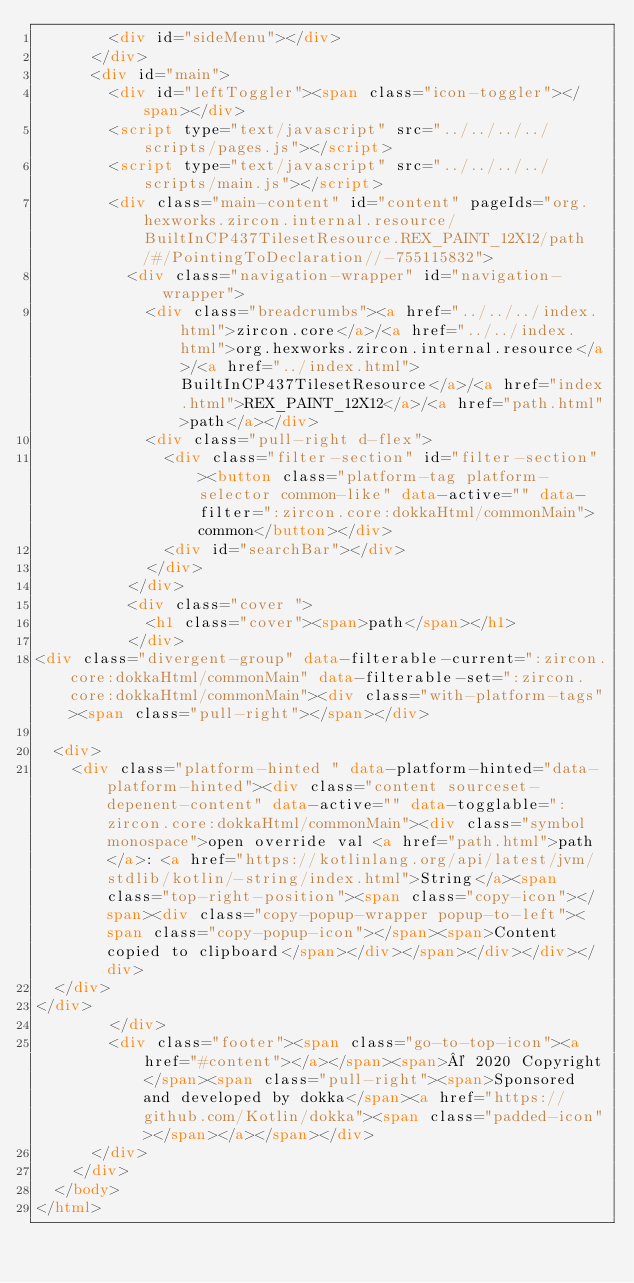<code> <loc_0><loc_0><loc_500><loc_500><_HTML_>        <div id="sideMenu"></div>
      </div>
      <div id="main">
        <div id="leftToggler"><span class="icon-toggler"></span></div>
        <script type="text/javascript" src="../../../../scripts/pages.js"></script>
        <script type="text/javascript" src="../../../../scripts/main.js"></script>
        <div class="main-content" id="content" pageIds="org.hexworks.zircon.internal.resource/BuiltInCP437TilesetResource.REX_PAINT_12X12/path/#/PointingToDeclaration//-755115832">
          <div class="navigation-wrapper" id="navigation-wrapper">
            <div class="breadcrumbs"><a href="../../../index.html">zircon.core</a>/<a href="../../index.html">org.hexworks.zircon.internal.resource</a>/<a href="../index.html">BuiltInCP437TilesetResource</a>/<a href="index.html">REX_PAINT_12X12</a>/<a href="path.html">path</a></div>
            <div class="pull-right d-flex">
              <div class="filter-section" id="filter-section"><button class="platform-tag platform-selector common-like" data-active="" data-filter=":zircon.core:dokkaHtml/commonMain">common</button></div>
              <div id="searchBar"></div>
            </div>
          </div>
          <div class="cover ">
            <h1 class="cover"><span>path</span></h1>
          </div>
<div class="divergent-group" data-filterable-current=":zircon.core:dokkaHtml/commonMain" data-filterable-set=":zircon.core:dokkaHtml/commonMain"><div class="with-platform-tags"><span class="pull-right"></span></div>

  <div>
    <div class="platform-hinted " data-platform-hinted="data-platform-hinted"><div class="content sourceset-depenent-content" data-active="" data-togglable=":zircon.core:dokkaHtml/commonMain"><div class="symbol monospace">open override val <a href="path.html">path</a>: <a href="https://kotlinlang.org/api/latest/jvm/stdlib/kotlin/-string/index.html">String</a><span class="top-right-position"><span class="copy-icon"></span><div class="copy-popup-wrapper popup-to-left"><span class="copy-popup-icon"></span><span>Content copied to clipboard</span></div></span></div></div></div>
  </div>
</div>
        </div>
        <div class="footer"><span class="go-to-top-icon"><a href="#content"></a></span><span>© 2020 Copyright</span><span class="pull-right"><span>Sponsored and developed by dokka</span><a href="https://github.com/Kotlin/dokka"><span class="padded-icon"></span></a></span></div>
      </div>
    </div>
  </body>
</html>

</code> 